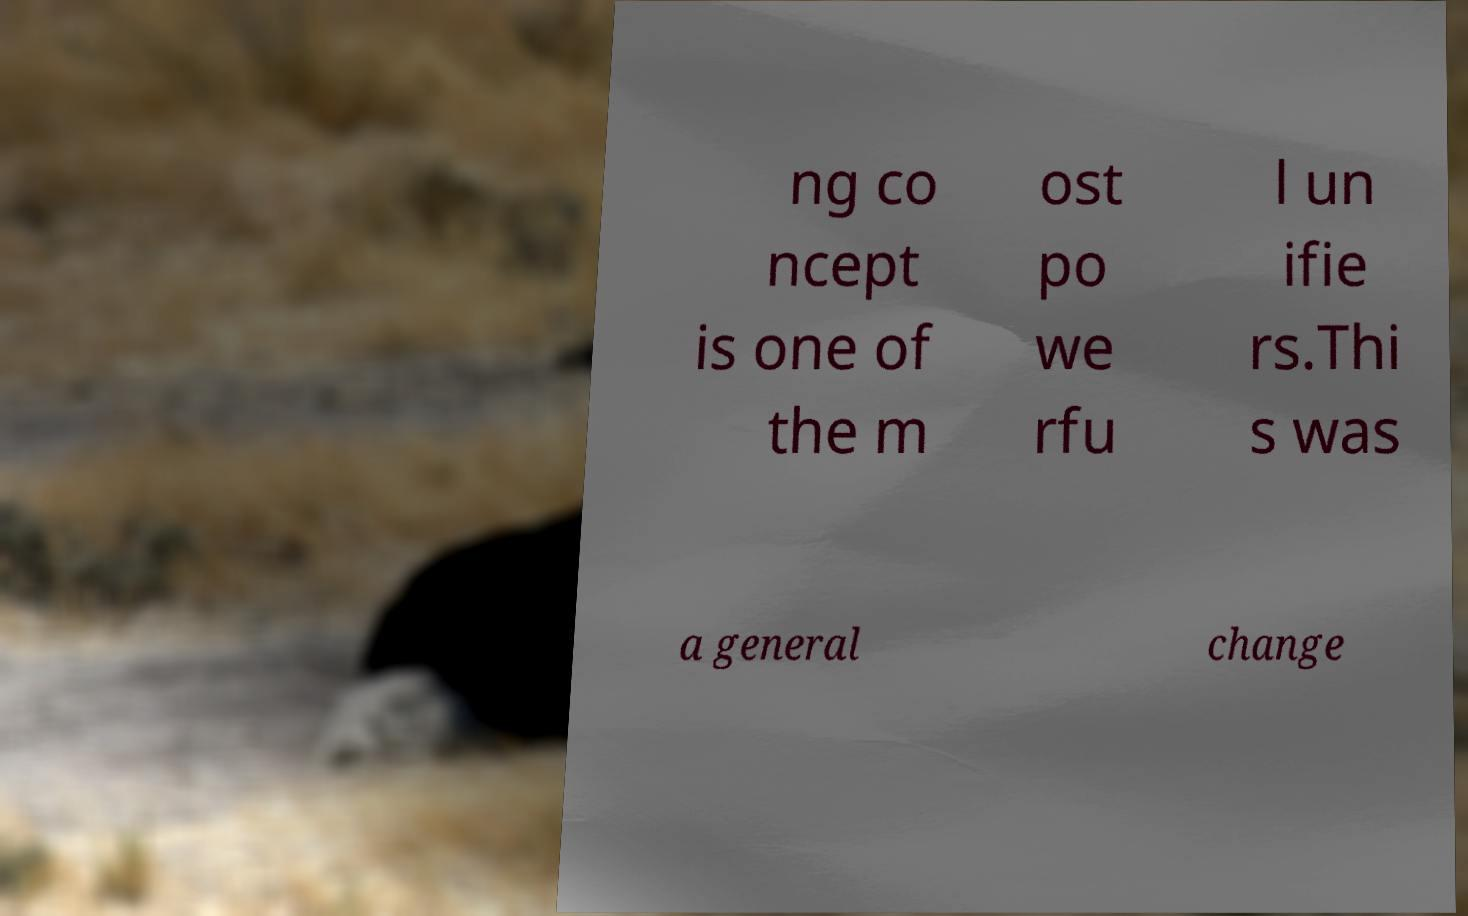There's text embedded in this image that I need extracted. Can you transcribe it verbatim? ng co ncept is one of the m ost po we rfu l un ifie rs.Thi s was a general change 